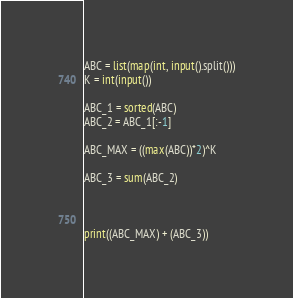<code> <loc_0><loc_0><loc_500><loc_500><_Python_>ABC = list(map(int, input().split()))
K = int(input())

ABC_1 = sorted(ABC)
ABC_2 = ABC_1[:-1]

ABC_MAX = ((max(ABC))*2)^K

ABC_3 = sum(ABC_2)



print((ABC_MAX) + (ABC_3))
</code> 